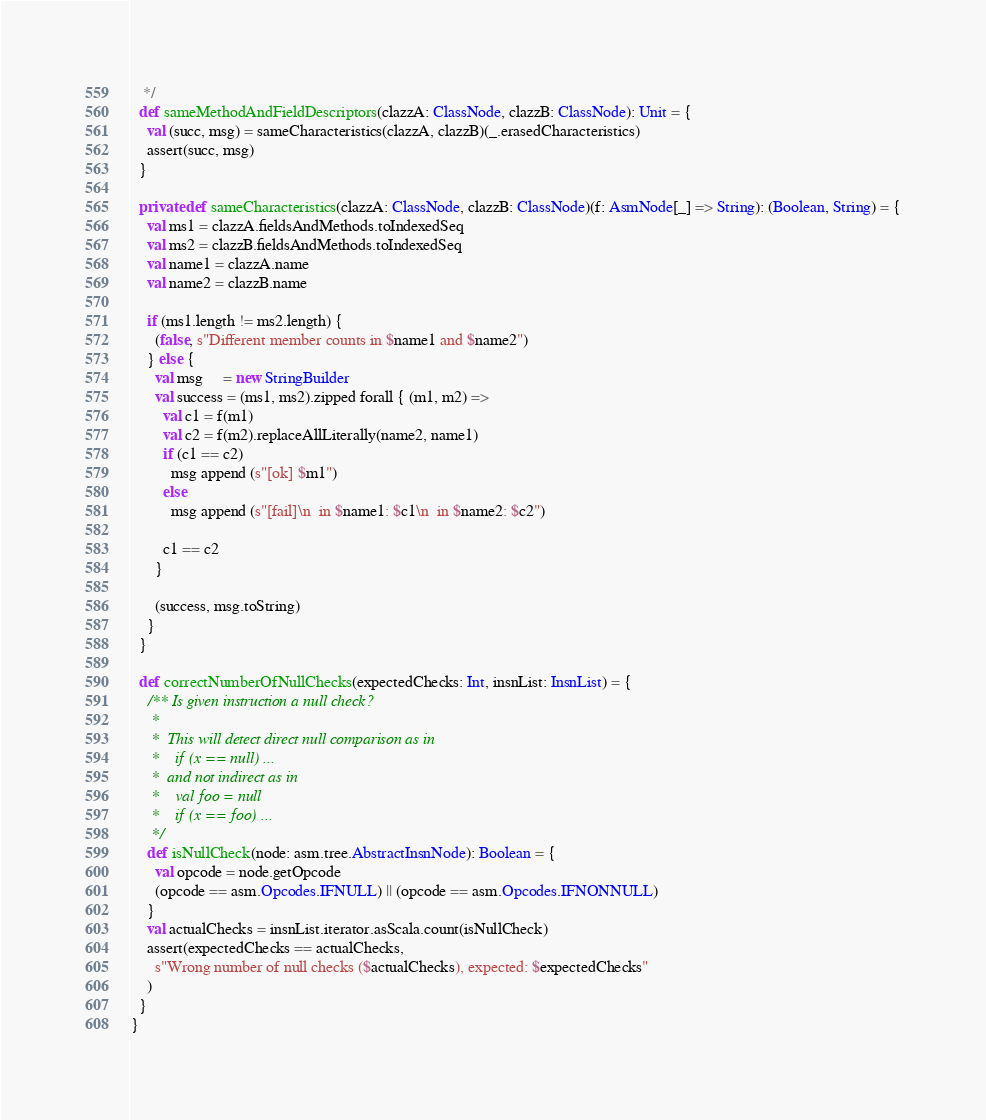<code> <loc_0><loc_0><loc_500><loc_500><_Scala_>   */
  def sameMethodAndFieldDescriptors(clazzA: ClassNode, clazzB: ClassNode): Unit = {
    val (succ, msg) = sameCharacteristics(clazzA, clazzB)(_.erasedCharacteristics)
    assert(succ, msg)
  }

  private def sameCharacteristics(clazzA: ClassNode, clazzB: ClassNode)(f: AsmNode[_] => String): (Boolean, String) = {
    val ms1 = clazzA.fieldsAndMethods.toIndexedSeq
    val ms2 = clazzB.fieldsAndMethods.toIndexedSeq
    val name1 = clazzA.name
    val name2 = clazzB.name

    if (ms1.length != ms2.length) {
      (false, s"Different member counts in $name1 and $name2")
    } else {
      val msg     = new StringBuilder
      val success = (ms1, ms2).zipped forall { (m1, m2) =>
        val c1 = f(m1)
        val c2 = f(m2).replaceAllLiterally(name2, name1)
        if (c1 == c2)
          msg append (s"[ok] $m1")
        else
          msg append (s"[fail]\n  in $name1: $c1\n  in $name2: $c2")

        c1 == c2
      }

      (success, msg.toString)
    }
  }

  def correctNumberOfNullChecks(expectedChecks: Int, insnList: InsnList) = {
    /** Is given instruction a null check?
     *
     *  This will detect direct null comparison as in
     *    if (x == null) ...
     *  and not indirect as in
     *    val foo = null
     *    if (x == foo) ...
     */
    def isNullCheck(node: asm.tree.AbstractInsnNode): Boolean = {
      val opcode = node.getOpcode
      (opcode == asm.Opcodes.IFNULL) || (opcode == asm.Opcodes.IFNONNULL)
    }
    val actualChecks = insnList.iterator.asScala.count(isNullCheck)
    assert(expectedChecks == actualChecks,
      s"Wrong number of null checks ($actualChecks), expected: $expectedChecks"
    )
  }
}
</code> 